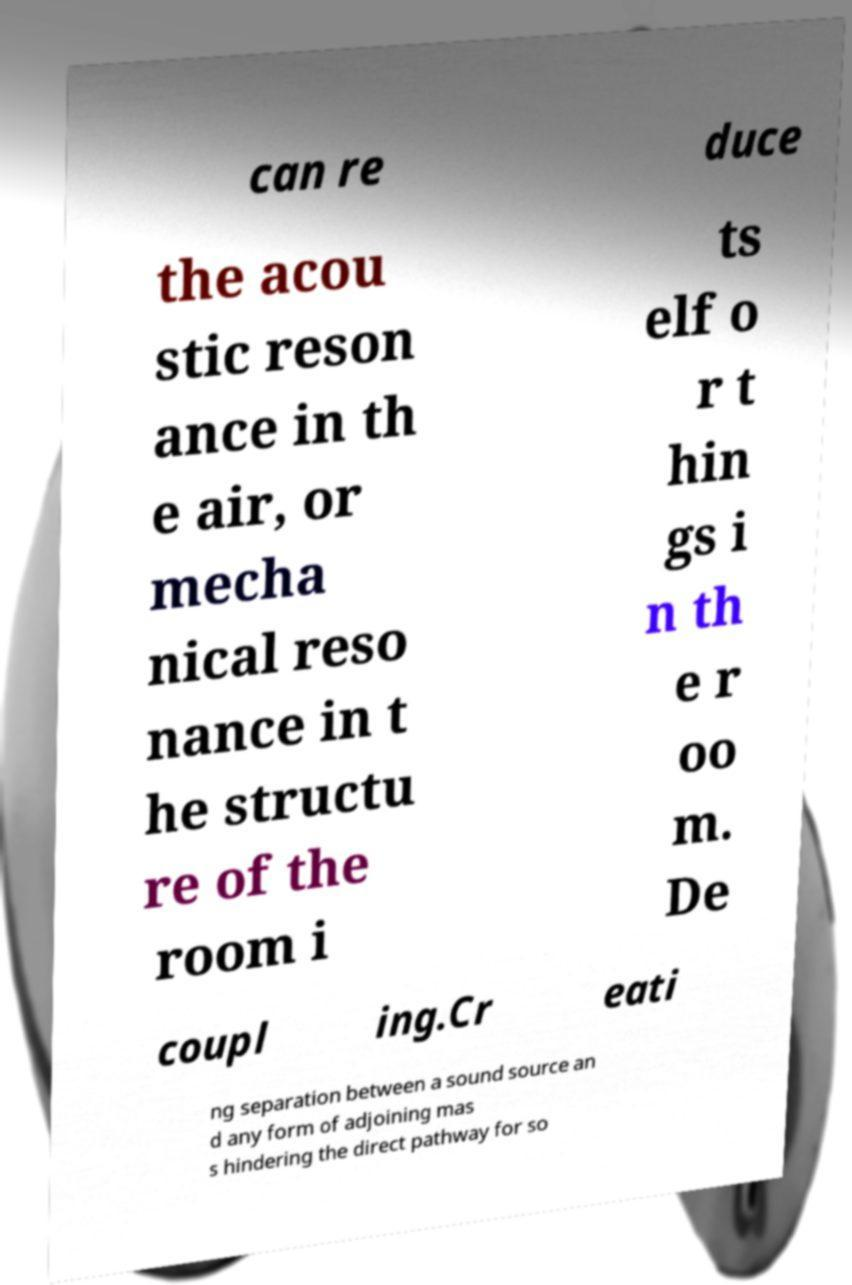Can you accurately transcribe the text from the provided image for me? can re duce the acou stic reson ance in th e air, or mecha nical reso nance in t he structu re of the room i ts elf o r t hin gs i n th e r oo m. De coupl ing.Cr eati ng separation between a sound source an d any form of adjoining mas s hindering the direct pathway for so 